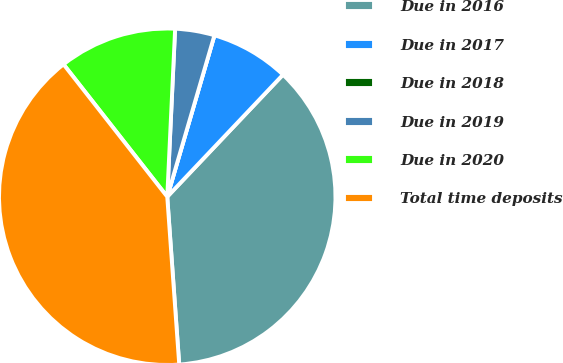<chart> <loc_0><loc_0><loc_500><loc_500><pie_chart><fcel>Due in 2016<fcel>Due in 2017<fcel>Due in 2018<fcel>Due in 2019<fcel>Due in 2020<fcel>Total time deposits<nl><fcel>36.79%<fcel>7.55%<fcel>0.0%<fcel>3.78%<fcel>11.32%<fcel>40.56%<nl></chart> 